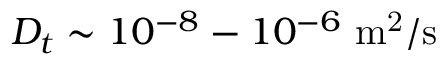Convert formula to latex. <formula><loc_0><loc_0><loc_500><loc_500>D _ { t } \sim 1 0 ^ { - 8 } - 1 0 ^ { - 6 } m ^ { 2 } / s</formula> 